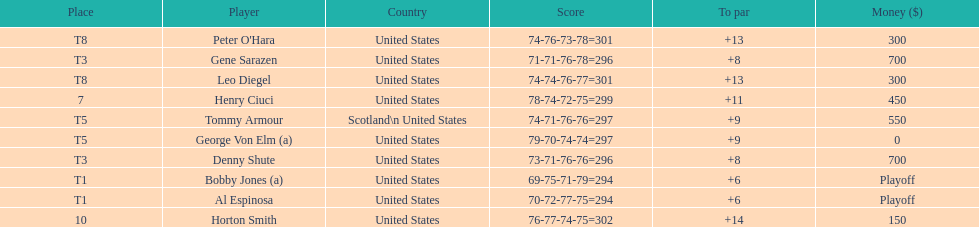Which two players tied for first place? Bobby Jones (a), Al Espinosa. 